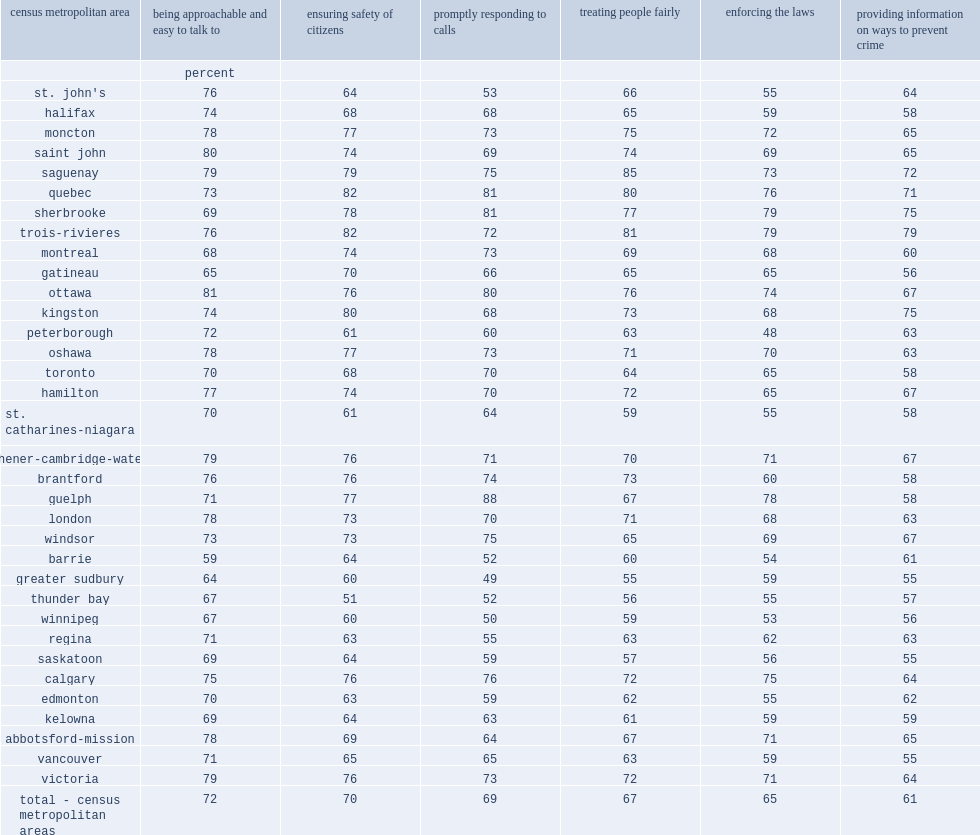Which region was leat favourable in their evaluation of local police. Vancouver winnipeg. 